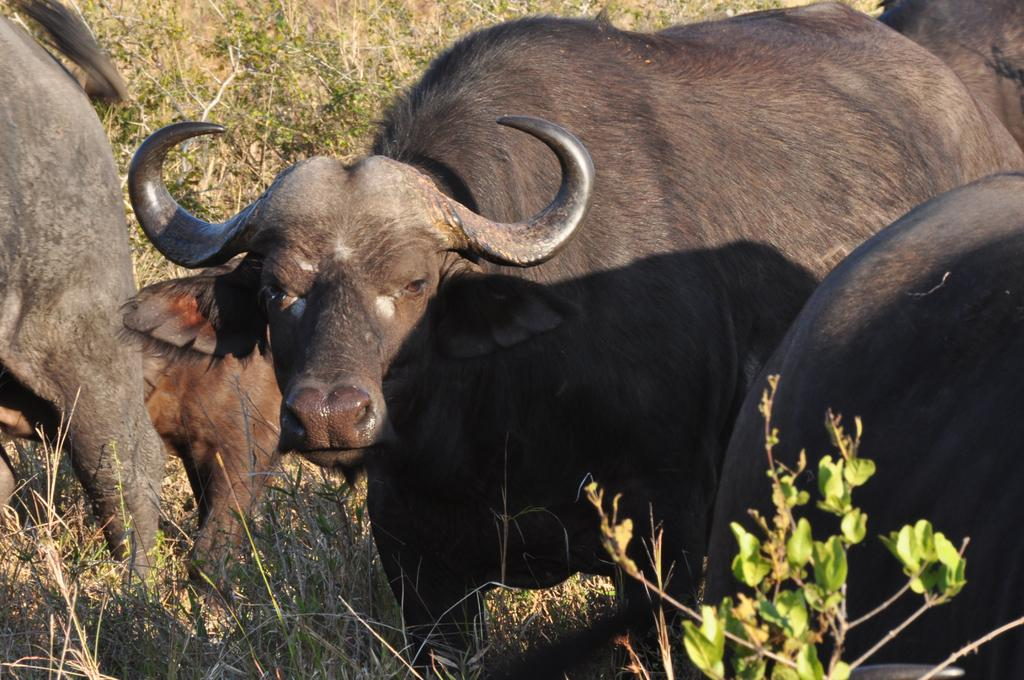What type of animals are in the image? There are buffaloes in the image. What can be seen in the background of the image? There are plants visible in the background of the image. What noise does the father make while spying on the buffaloes in the image? There is no father or spying depicted in the image; it simply shows buffaloes and plants in the background. 